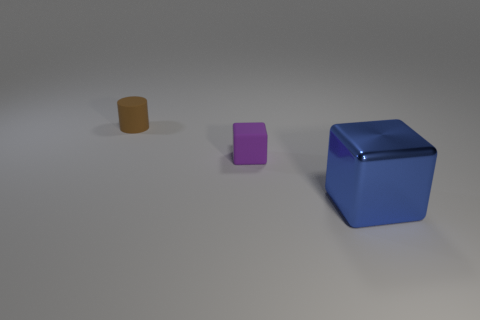Subtract all blue blocks. Subtract all brown balls. How many blocks are left? 1 Add 2 rubber cylinders. How many objects exist? 5 Subtract all cubes. How many objects are left? 1 Subtract all large cyan shiny things. Subtract all large metallic things. How many objects are left? 2 Add 3 tiny rubber cylinders. How many tiny rubber cylinders are left? 4 Add 3 tiny cylinders. How many tiny cylinders exist? 4 Subtract 0 blue spheres. How many objects are left? 3 